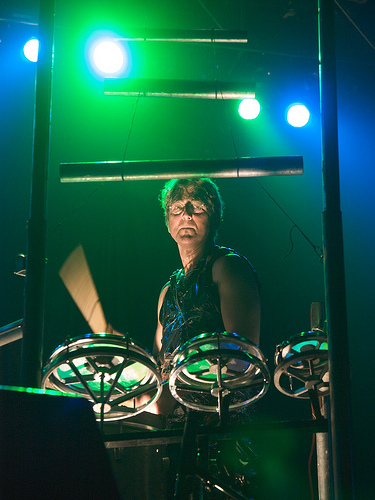<image>
Is there a drum to the left of the drummer? No. The drum is not to the left of the drummer. From this viewpoint, they have a different horizontal relationship. 